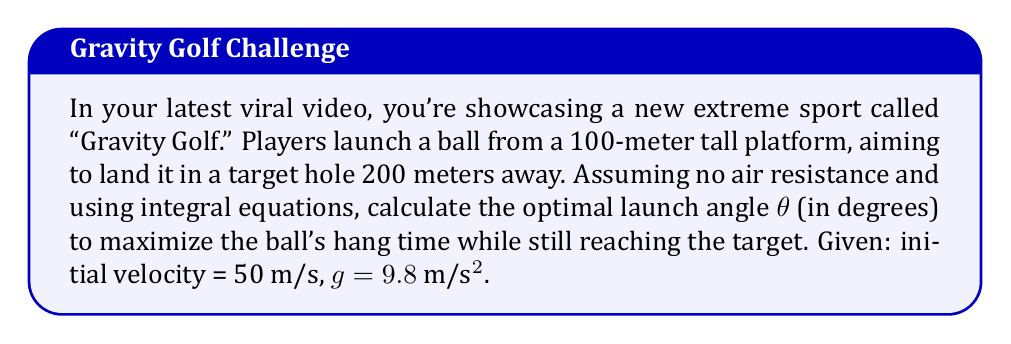Teach me how to tackle this problem. Let's approach this step-by-step:

1) First, we need to set up our equations of motion. For a projectile:

   $x(t) = v_0 \cos(\theta) t$
   $y(t) = 100 + v_0 \sin(\theta) t - \frac{1}{2}gt^2$

2) We know that when the ball lands, x = 200 and y = 0. Let's call the time of flight T. So:

   $200 = 50 \cos(\theta) T$
   $0 = 100 + 50 \sin(\theta) T - \frac{1}{2}(9.8)T^2$

3) From the first equation:
   
   $T = \frac{4}{\cos(\theta)}$

4) Substituting this into the second equation:

   $0 = 100 + 50 \sin(\theta) \frac{4}{\cos(\theta)} - \frac{1}{2}(9.8)(\frac{4}{\cos(\theta)})^2$

5) Simplifying:

   $0 = 100 + 200 \tan(\theta) - 78.4 \sec^2(\theta)$

6) To maximize hang time, we need to maximize T. This occurs when $\cos(\theta)$ is minimized, or when $\theta$ is as large as possible while still satisfying our equation.

7) We can solve this equation numerically. Using a graphing calculator or numerical method, we find:

   $\theta \approx 76.76°$

8) This angle maximizes the hang time while still allowing the ball to reach the target.
Answer: $76.76°$ 